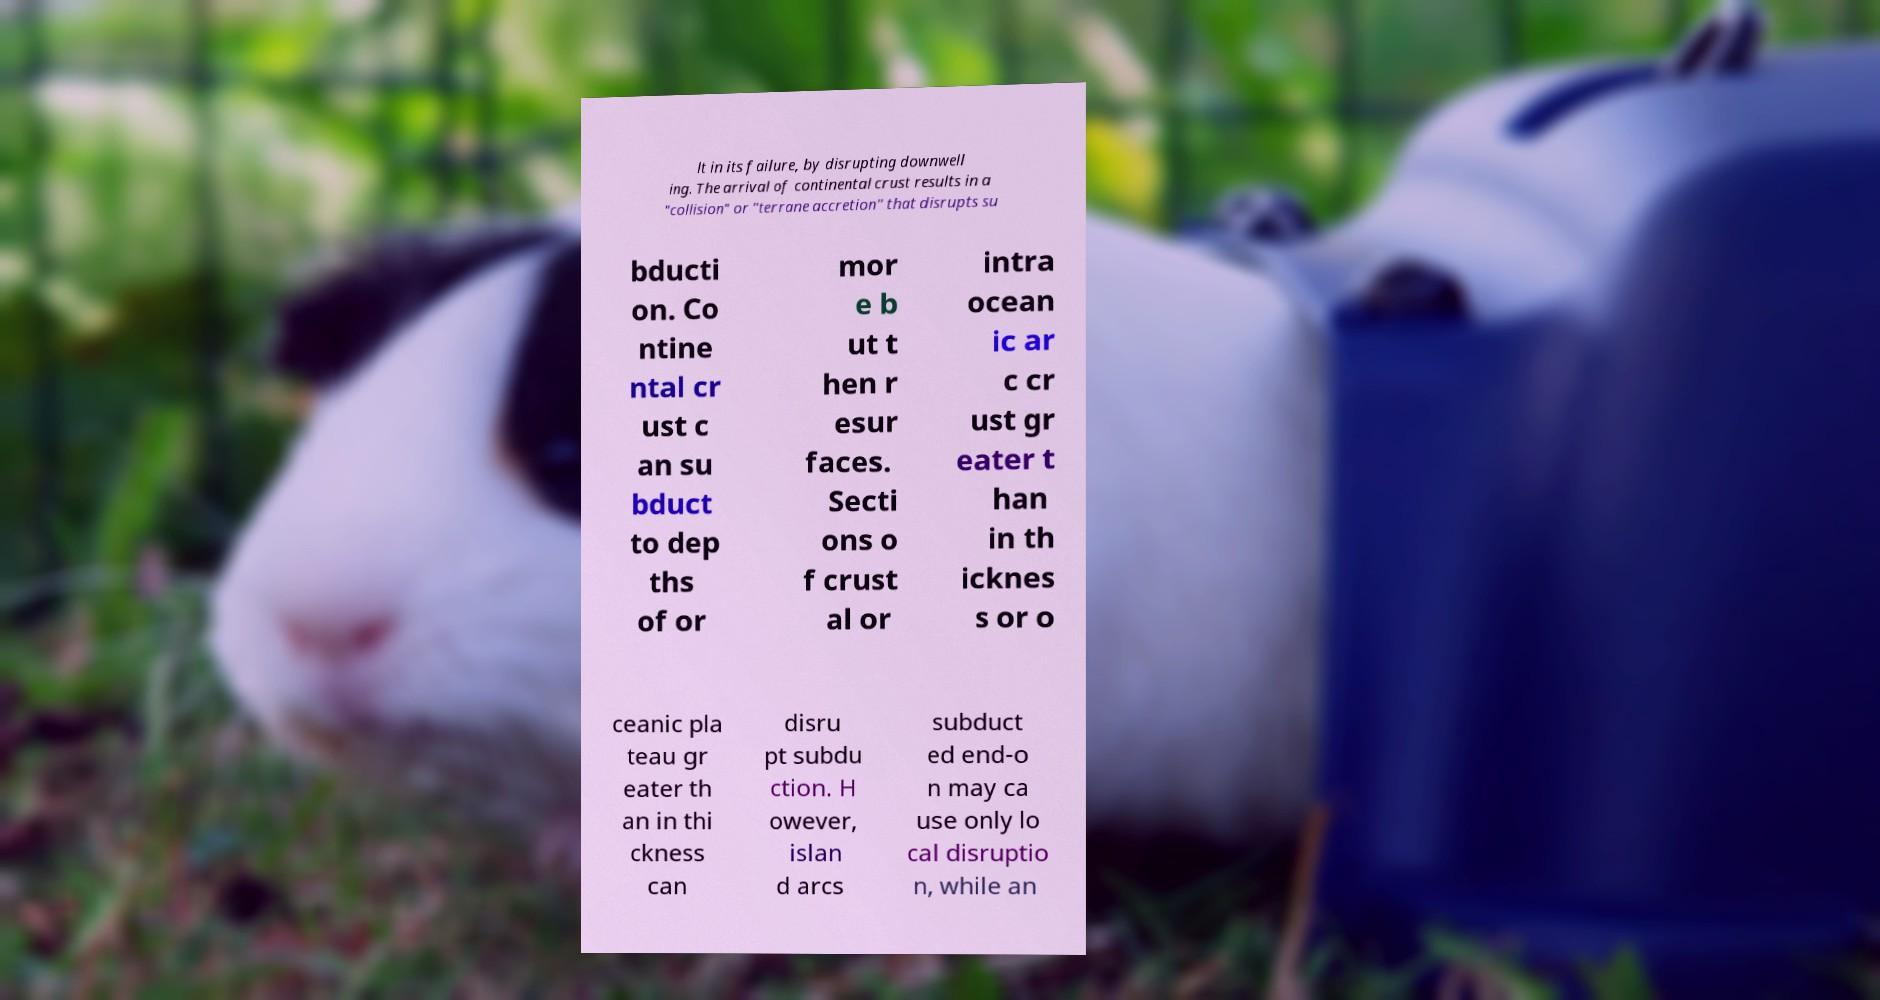What messages or text are displayed in this image? I need them in a readable, typed format. lt in its failure, by disrupting downwell ing. The arrival of continental crust results in a "collision" or "terrane accretion" that disrupts su bducti on. Co ntine ntal cr ust c an su bduct to dep ths of or mor e b ut t hen r esur faces. Secti ons o f crust al or intra ocean ic ar c cr ust gr eater t han in th icknes s or o ceanic pla teau gr eater th an in thi ckness can disru pt subdu ction. H owever, islan d arcs subduct ed end-o n may ca use only lo cal disruptio n, while an 